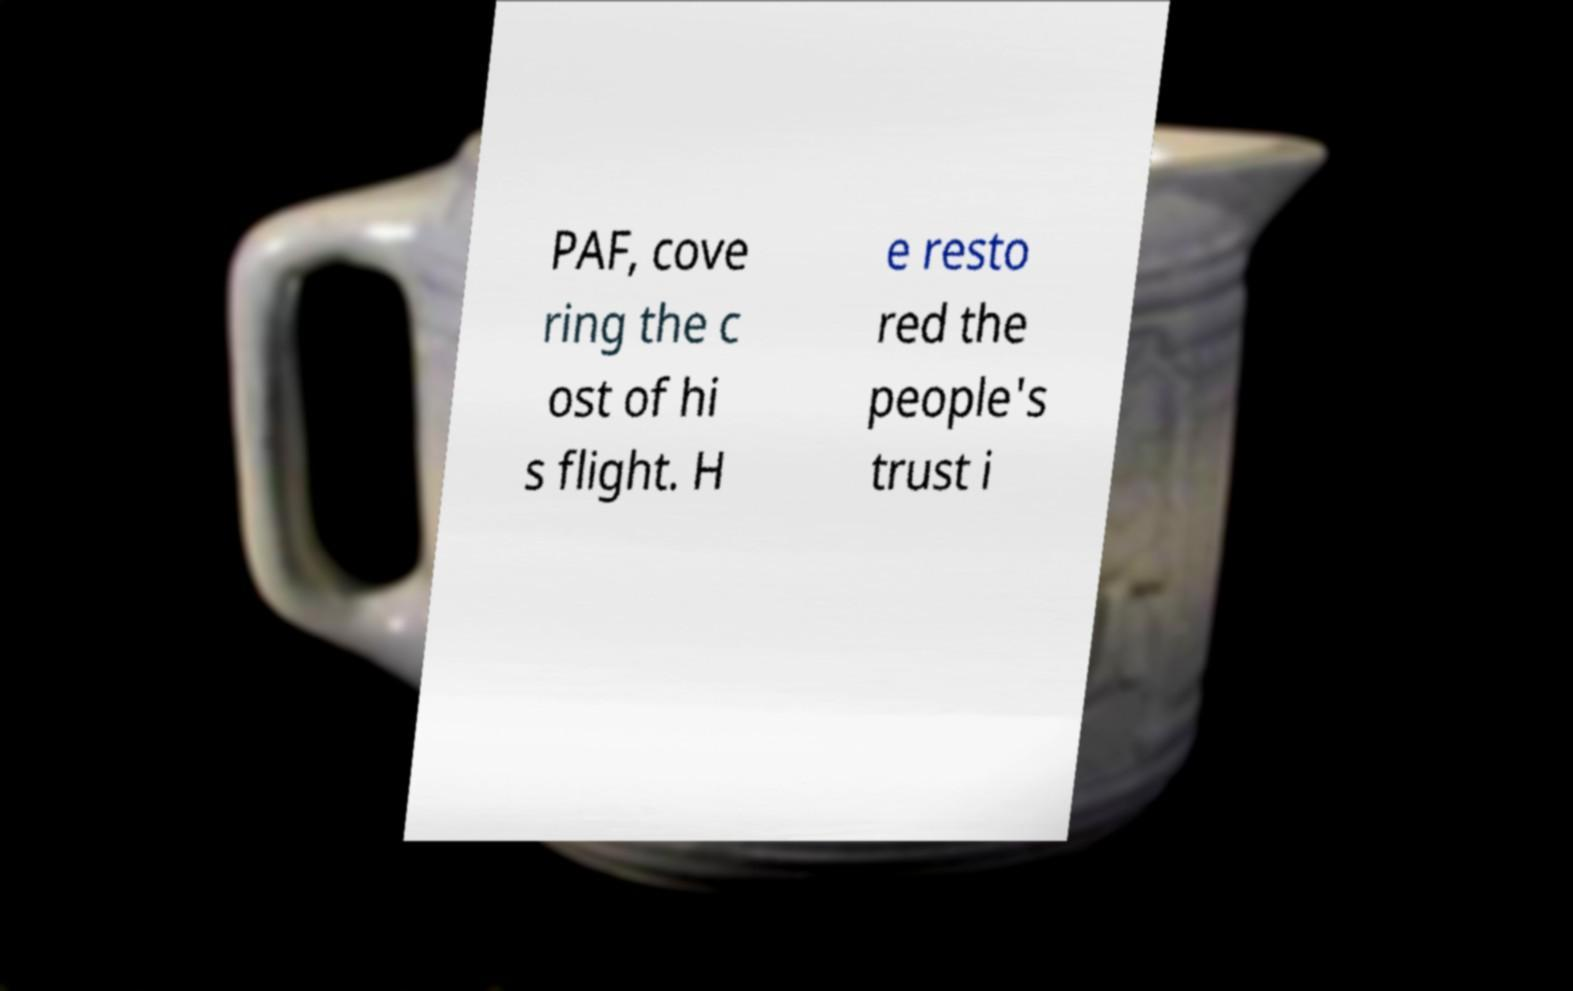There's text embedded in this image that I need extracted. Can you transcribe it verbatim? PAF, cove ring the c ost of hi s flight. H e resto red the people's trust i 